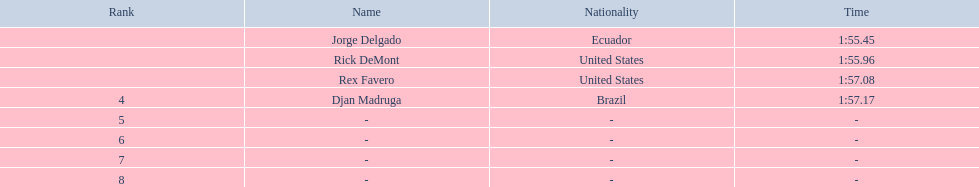Who finished with the top time? Jorge Delgado. 